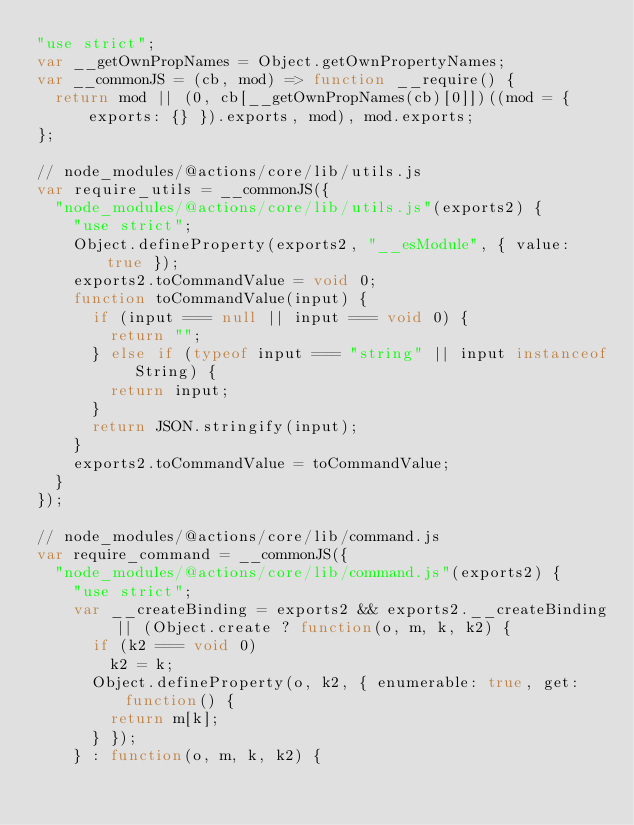<code> <loc_0><loc_0><loc_500><loc_500><_JavaScript_>"use strict";
var __getOwnPropNames = Object.getOwnPropertyNames;
var __commonJS = (cb, mod) => function __require() {
  return mod || (0, cb[__getOwnPropNames(cb)[0]])((mod = { exports: {} }).exports, mod), mod.exports;
};

// node_modules/@actions/core/lib/utils.js
var require_utils = __commonJS({
  "node_modules/@actions/core/lib/utils.js"(exports2) {
    "use strict";
    Object.defineProperty(exports2, "__esModule", { value: true });
    exports2.toCommandValue = void 0;
    function toCommandValue(input) {
      if (input === null || input === void 0) {
        return "";
      } else if (typeof input === "string" || input instanceof String) {
        return input;
      }
      return JSON.stringify(input);
    }
    exports2.toCommandValue = toCommandValue;
  }
});

// node_modules/@actions/core/lib/command.js
var require_command = __commonJS({
  "node_modules/@actions/core/lib/command.js"(exports2) {
    "use strict";
    var __createBinding = exports2 && exports2.__createBinding || (Object.create ? function(o, m, k, k2) {
      if (k2 === void 0)
        k2 = k;
      Object.defineProperty(o, k2, { enumerable: true, get: function() {
        return m[k];
      } });
    } : function(o, m, k, k2) {</code> 